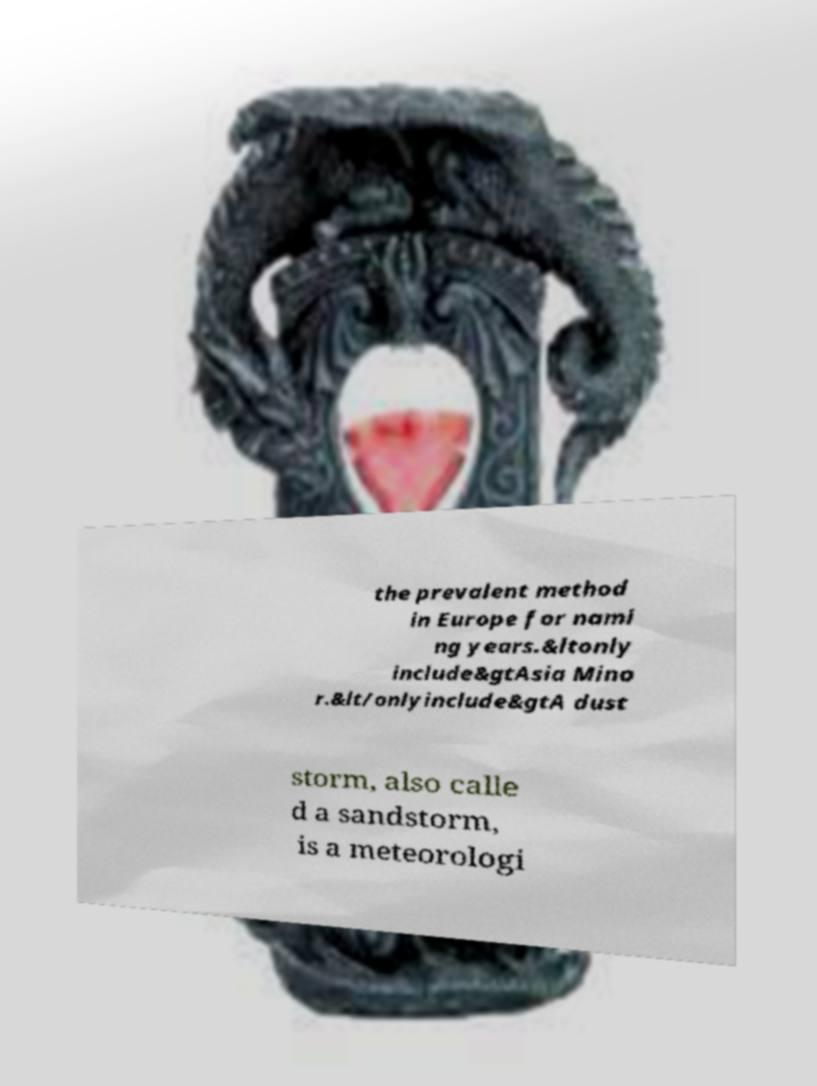For documentation purposes, I need the text within this image transcribed. Could you provide that? the prevalent method in Europe for nami ng years.&ltonly include&gtAsia Mino r.&lt/onlyinclude&gtA dust storm, also calle d a sandstorm, is a meteorologi 